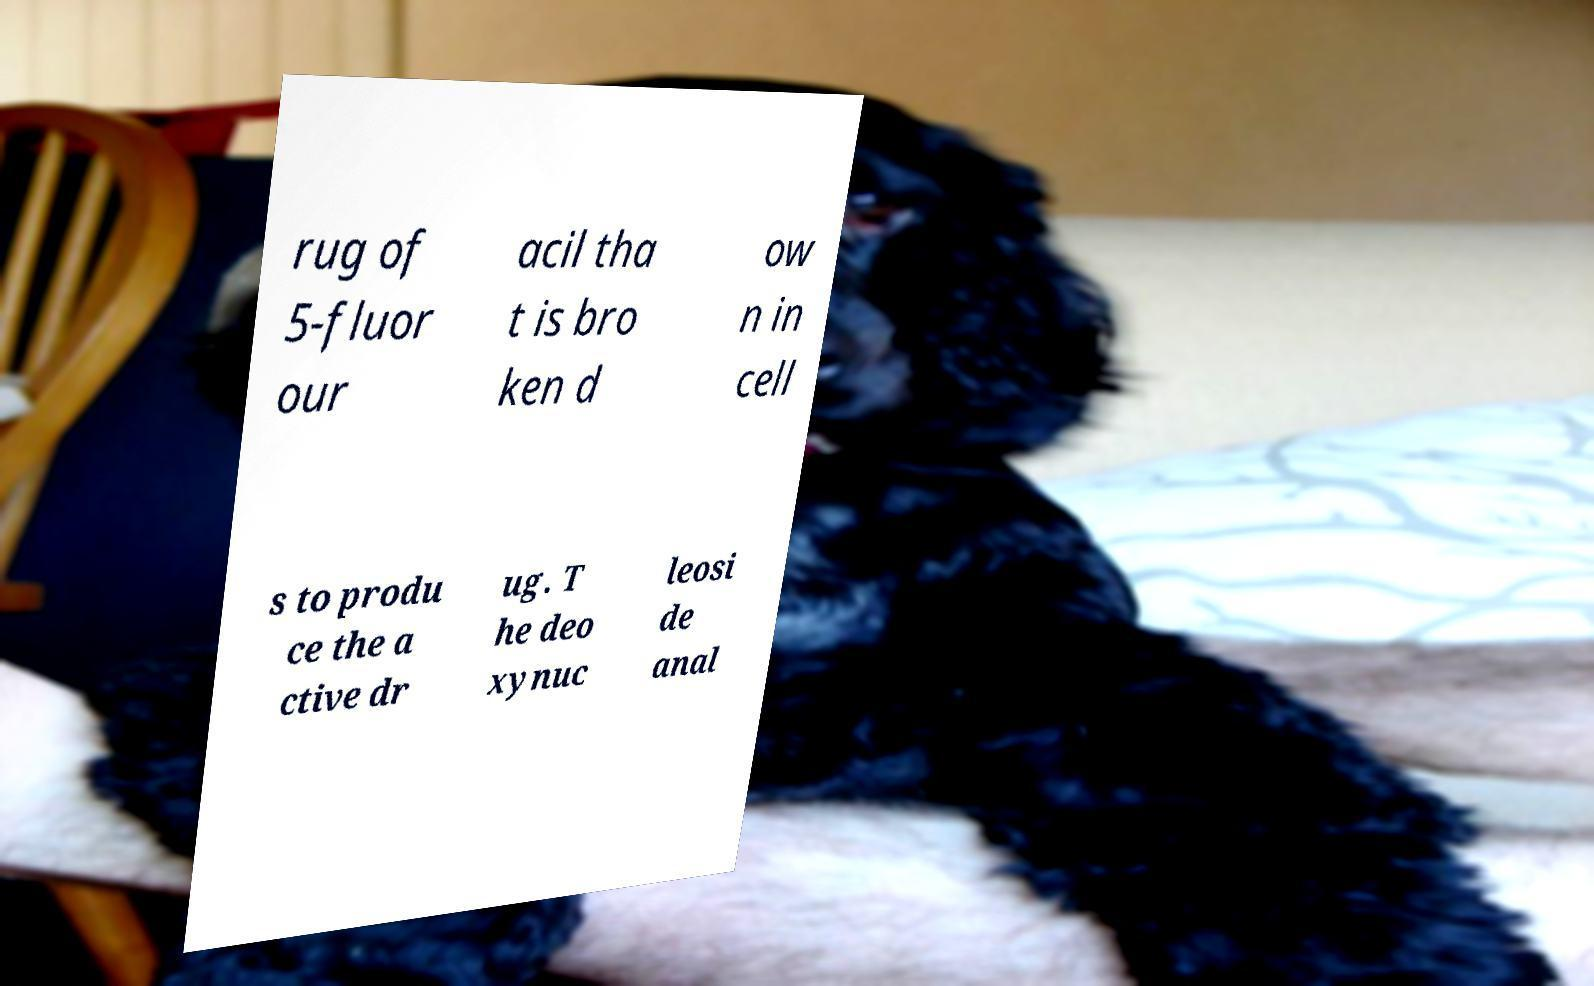Can you accurately transcribe the text from the provided image for me? rug of 5-fluor our acil tha t is bro ken d ow n in cell s to produ ce the a ctive dr ug. T he deo xynuc leosi de anal 